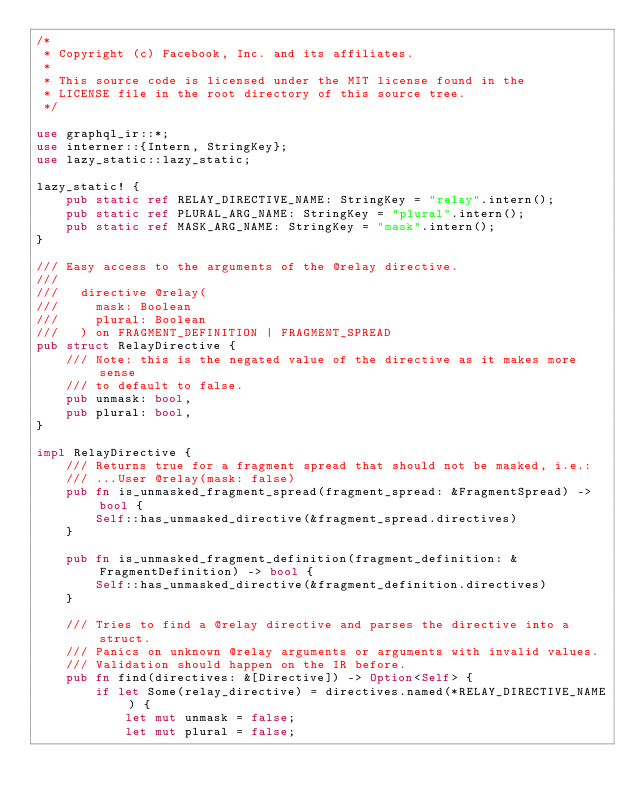Convert code to text. <code><loc_0><loc_0><loc_500><loc_500><_Rust_>/*
 * Copyright (c) Facebook, Inc. and its affiliates.
 *
 * This source code is licensed under the MIT license found in the
 * LICENSE file in the root directory of this source tree.
 */

use graphql_ir::*;
use interner::{Intern, StringKey};
use lazy_static::lazy_static;

lazy_static! {
    pub static ref RELAY_DIRECTIVE_NAME: StringKey = "relay".intern();
    pub static ref PLURAL_ARG_NAME: StringKey = "plural".intern();
    pub static ref MASK_ARG_NAME: StringKey = "mask".intern();
}

/// Easy access to the arguments of the @relay directive.
///
///   directive @relay(
///     mask: Boolean
///     plural: Boolean
///   ) on FRAGMENT_DEFINITION | FRAGMENT_SPREAD
pub struct RelayDirective {
    /// Note: this is the negated value of the directive as it makes more sense
    /// to default to false.
    pub unmask: bool,
    pub plural: bool,
}

impl RelayDirective {
    /// Returns true for a fragment spread that should not be masked, i.e.:
    /// ...User @relay(mask: false)
    pub fn is_unmasked_fragment_spread(fragment_spread: &FragmentSpread) -> bool {
        Self::has_unmasked_directive(&fragment_spread.directives)
    }

    pub fn is_unmasked_fragment_definition(fragment_definition: &FragmentDefinition) -> bool {
        Self::has_unmasked_directive(&fragment_definition.directives)
    }

    /// Tries to find a @relay directive and parses the directive into a struct.
    /// Panics on unknown @relay arguments or arguments with invalid values.
    /// Validation should happen on the IR before.
    pub fn find(directives: &[Directive]) -> Option<Self> {
        if let Some(relay_directive) = directives.named(*RELAY_DIRECTIVE_NAME) {
            let mut unmask = false;
            let mut plural = false;</code> 